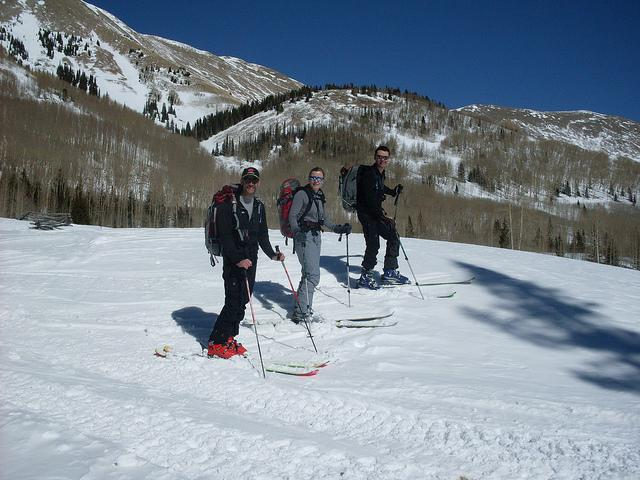Why are they off the path?

Choices:
A) fighting
B) confused
C) buying tickets
D) posing posing 